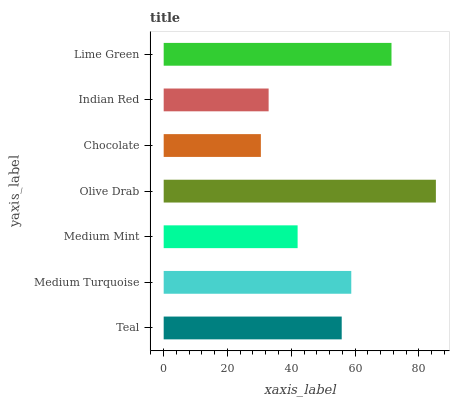Is Chocolate the minimum?
Answer yes or no. Yes. Is Olive Drab the maximum?
Answer yes or no. Yes. Is Medium Turquoise the minimum?
Answer yes or no. No. Is Medium Turquoise the maximum?
Answer yes or no. No. Is Medium Turquoise greater than Teal?
Answer yes or no. Yes. Is Teal less than Medium Turquoise?
Answer yes or no. Yes. Is Teal greater than Medium Turquoise?
Answer yes or no. No. Is Medium Turquoise less than Teal?
Answer yes or no. No. Is Teal the high median?
Answer yes or no. Yes. Is Teal the low median?
Answer yes or no. Yes. Is Indian Red the high median?
Answer yes or no. No. Is Olive Drab the low median?
Answer yes or no. No. 